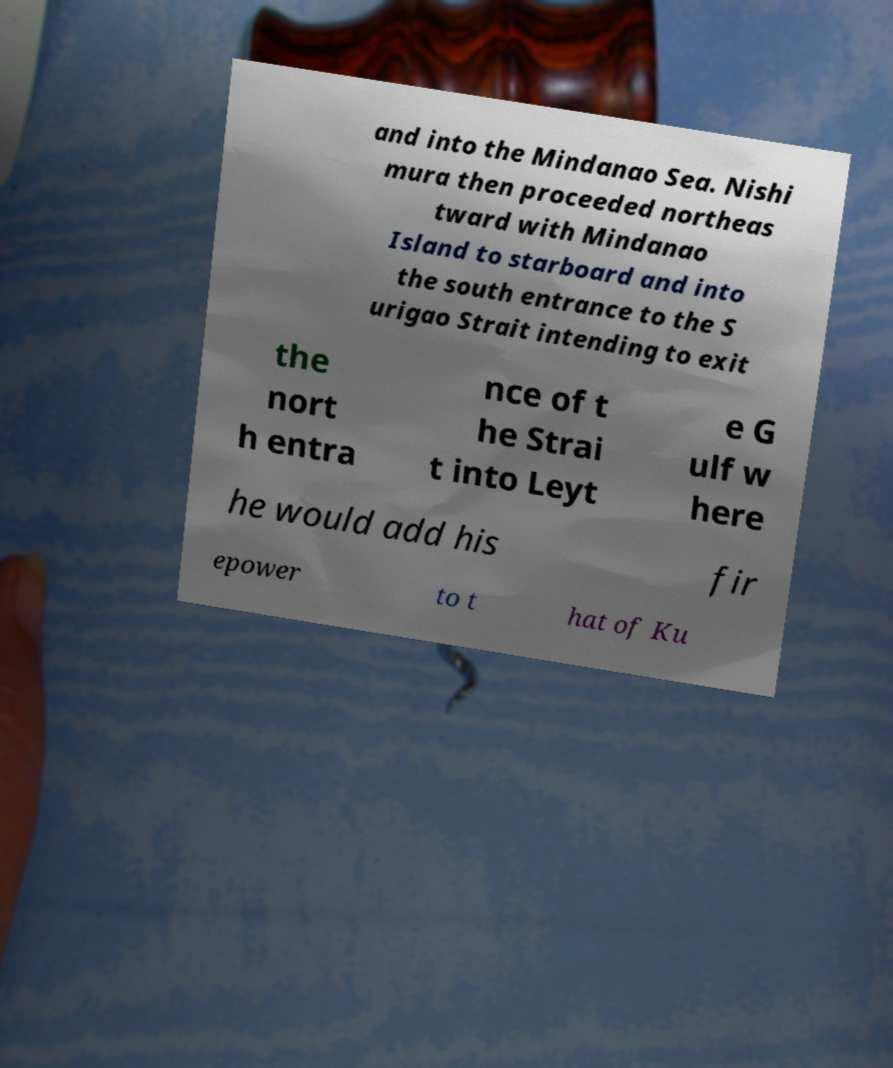I need the written content from this picture converted into text. Can you do that? and into the Mindanao Sea. Nishi mura then proceeded northeas tward with Mindanao Island to starboard and into the south entrance to the S urigao Strait intending to exit the nort h entra nce of t he Strai t into Leyt e G ulf w here he would add his fir epower to t hat of Ku 